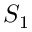<formula> <loc_0><loc_0><loc_500><loc_500>S _ { 1 }</formula> 